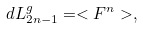Convert formula to latex. <formula><loc_0><loc_0><loc_500><loc_500>d L _ { 2 n - 1 } ^ { g } = < { F } ^ { n } > ,</formula> 